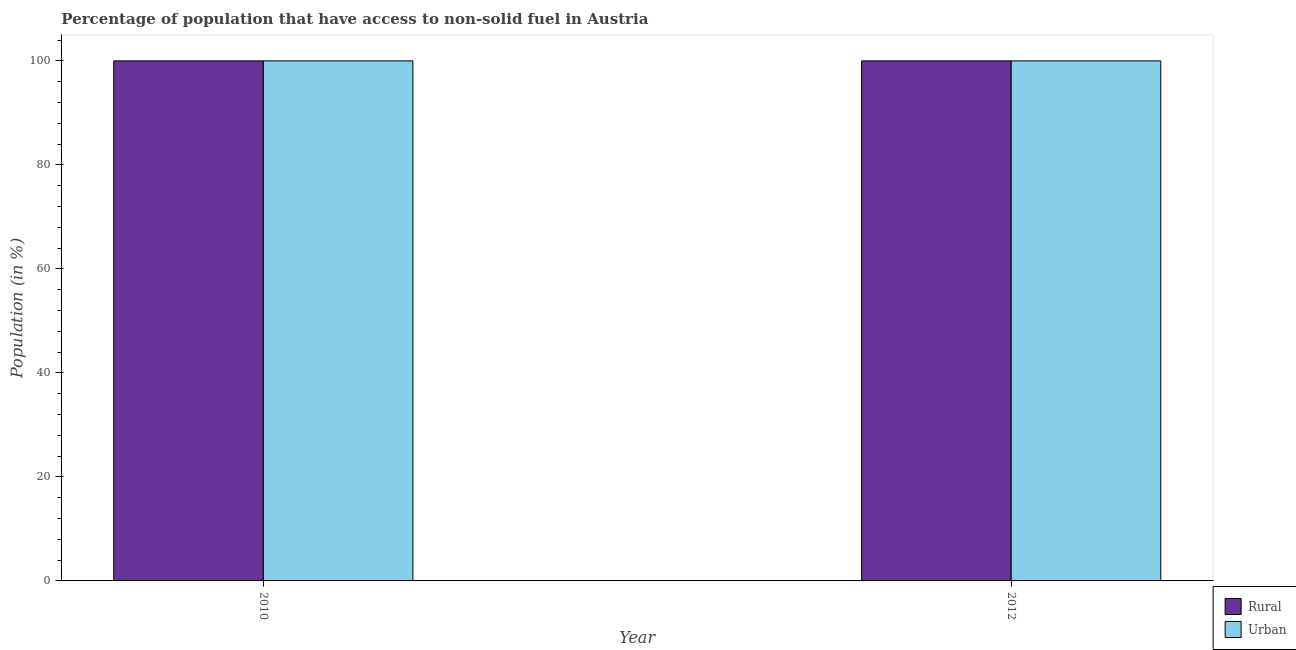How many different coloured bars are there?
Your answer should be very brief. 2. How many groups of bars are there?
Keep it short and to the point. 2. Are the number of bars per tick equal to the number of legend labels?
Give a very brief answer. Yes. Are the number of bars on each tick of the X-axis equal?
Your answer should be compact. Yes. How many bars are there on the 2nd tick from the left?
Provide a succinct answer. 2. In how many cases, is the number of bars for a given year not equal to the number of legend labels?
Offer a very short reply. 0. What is the urban population in 2010?
Your response must be concise. 100. Across all years, what is the maximum rural population?
Your response must be concise. 100. Across all years, what is the minimum rural population?
Give a very brief answer. 100. In which year was the rural population maximum?
Provide a succinct answer. 2010. In which year was the rural population minimum?
Give a very brief answer. 2010. What is the total urban population in the graph?
Provide a succinct answer. 200. What is the average rural population per year?
Provide a short and direct response. 100. In how many years, is the urban population greater than 92 %?
Provide a short and direct response. 2. What is the ratio of the rural population in 2010 to that in 2012?
Provide a short and direct response. 1. Is the rural population in 2010 less than that in 2012?
Give a very brief answer. No. In how many years, is the rural population greater than the average rural population taken over all years?
Give a very brief answer. 0. What does the 1st bar from the left in 2012 represents?
Keep it short and to the point. Rural. What does the 2nd bar from the right in 2010 represents?
Offer a very short reply. Rural. How many years are there in the graph?
Keep it short and to the point. 2. Where does the legend appear in the graph?
Make the answer very short. Bottom right. How many legend labels are there?
Provide a succinct answer. 2. How are the legend labels stacked?
Ensure brevity in your answer.  Vertical. What is the title of the graph?
Ensure brevity in your answer.  Percentage of population that have access to non-solid fuel in Austria. What is the label or title of the X-axis?
Provide a short and direct response. Year. What is the Population (in %) in Rural in 2010?
Offer a terse response. 100. What is the Population (in %) in Urban in 2010?
Keep it short and to the point. 100. Across all years, what is the maximum Population (in %) of Urban?
Make the answer very short. 100. What is the total Population (in %) of Rural in the graph?
Give a very brief answer. 200. What is the difference between the Population (in %) of Rural in 2010 and that in 2012?
Provide a succinct answer. 0. What is the difference between the Population (in %) of Urban in 2010 and that in 2012?
Provide a short and direct response. 0. In the year 2012, what is the difference between the Population (in %) in Rural and Population (in %) in Urban?
Ensure brevity in your answer.  0. What is the ratio of the Population (in %) in Urban in 2010 to that in 2012?
Your answer should be compact. 1. What is the difference between the highest and the lowest Population (in %) in Rural?
Make the answer very short. 0. 